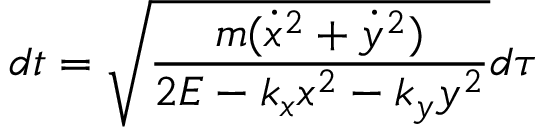<formula> <loc_0><loc_0><loc_500><loc_500>d t = \sqrt { \frac { m ( \dot { x } ^ { 2 } + \dot { y } ^ { 2 } ) } { 2 E - k _ { x } x ^ { 2 } - k _ { y } y ^ { 2 } } } d \tau</formula> 